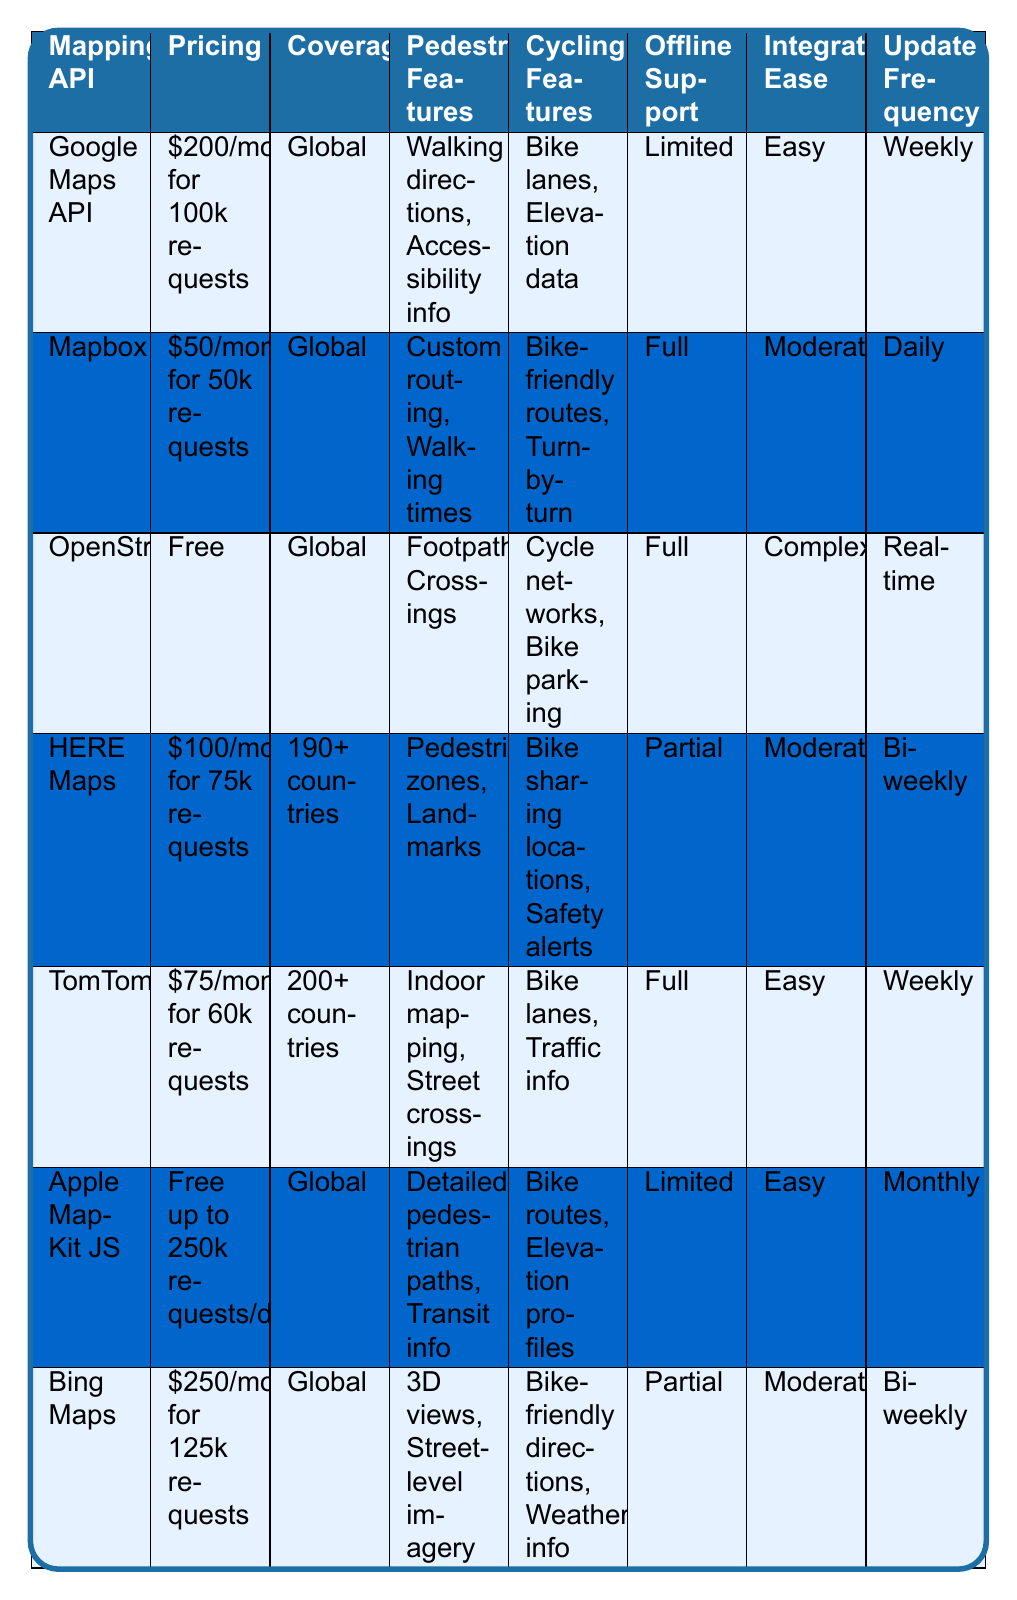What is the pricing for OpenStreetMap API? The pricing for OpenStreetMap API is listed in the second column of the table, where it shows "Free."
Answer: Free Which mapping API has the most comprehensive offline support? The offline support for each API is listed in the sixth column. OpenStreetMap, Mapbox, and TomTom have full offline support.
Answer: OpenStreetMap, Mapbox, TomTom Is HERE Maps available globally? The coverage for HERE Maps is specified in the third column as "190+ countries," which means it is not available globally.
Answer: No Which mapping API is the most cost-effective for 50,000 requests? To find the most cost-effective API for 50,000 requests, we look at the pricing. Mapbox charges $50/month, which is the lowest compared to others for that request number.
Answer: Mapbox What is the average monthly cost of the top three paid APIs? The monthly costs of the top three paid APIs are Google Maps at $200, HERE Maps at $100, and TomTom at $75. Adding these together gives $200 + $100 + $75 = $375. Dividing by 3 gives an average of $125.
Answer: $125 Which API provides safety alerts for cyclists? In the cycling features column, HERE Maps is noted to provide "Safety alerts," thus answering the question affirmatively.
Answer: HERE Maps If a developer wants the best pedestrian features, which API should they choose? The best pedestrian features can be identified by comparing the pedestrian features listed in the fourth column. The detailed pedestrian paths and transit info offered by Apple MapKit JS stand out as highly beneficial.
Answer: Apple MapKit JS Which API has the highest update frequency? The update frequency of each API in the last column shows that Mapbox has the highest update frequency at "Daily."
Answer: Mapbox Are there any APIs that offer free usage? The table indicates clearly that OpenStreetMap is listed as free, as is Apple MapKit JS for up to 250,000 requests a day. Thus, there are APIs with free usage.
Answer: Yes Which API allows integration without much difficulty? By examining the integration ease in the seventh column, both Google Maps API and TomTom are noted as "Easy," suggesting a user-friendly experience.
Answer: Google Maps API, TomTom 